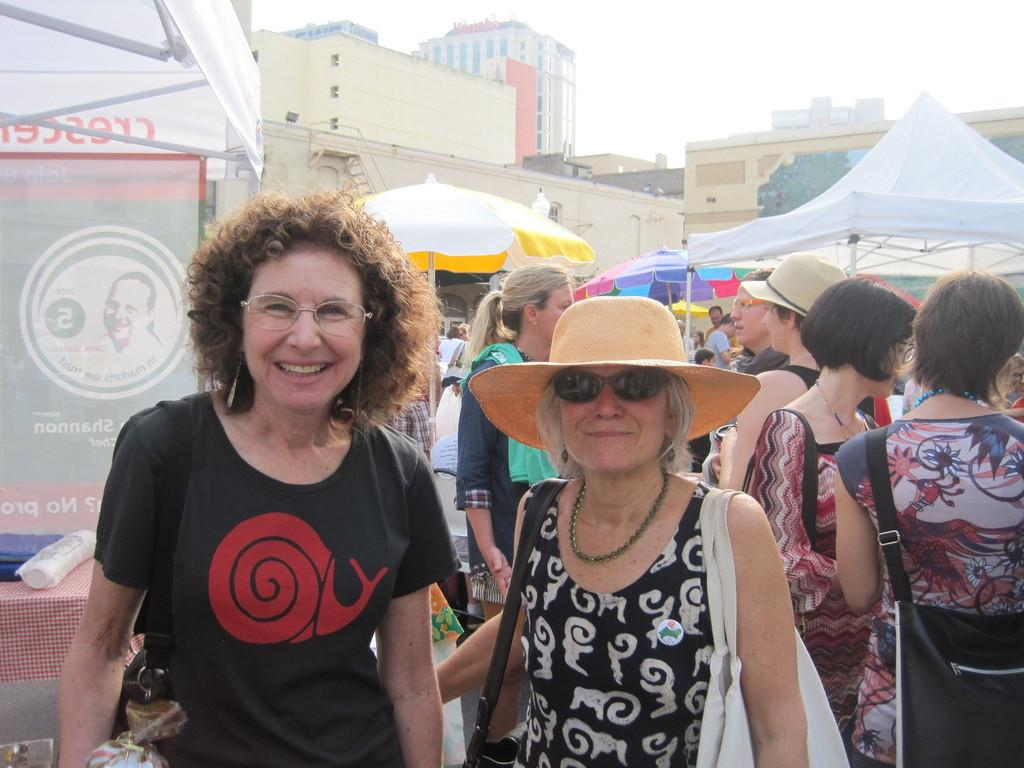What type of structures can be seen in the image? There are buildings in the image. What part of the natural environment is visible in the image? The sky is visible in the image. What temporary shelters are present in the image? There are tents in the image. What type of signage can be seen in the image? Advertisement boards are present in the image. What are the persons in the image doing? There are persons on the floor in the image. What type of stove can be seen in the image? There is no stove present in the image. How many cattle are visible in the image? There are no cattle visible in the image. 